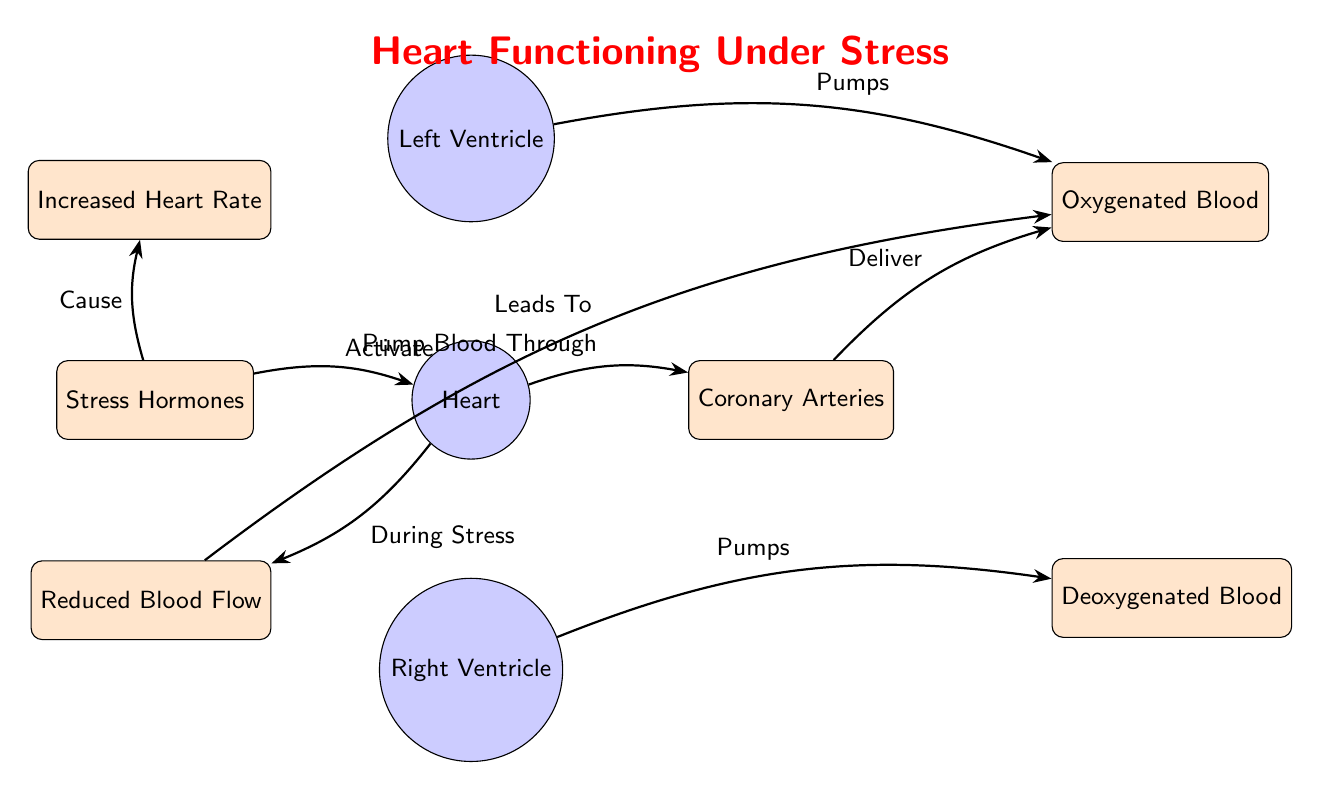What activates the heart during stress? The diagram indicates that "Stress Hormones" are responsible for activating the heart during stress as shown by the arrow from the "Stress Hormones" node to the "Heart" node labeled "Activate".
Answer: Stress Hormones What does the heart pump blood through? The diagram shows that the heart pumps blood through the "Coronary Arteries," as indicated by the arrow labeled "Pump Blood Through" from the heart to the coronary arteries.
Answer: Coronary Arteries How many processes are present in the diagram? There are three process nodes illustrated in the diagram: "Heart," "Left Ventricle," and "Right Ventricle." Counting these gives a total of three processes.
Answer: 3 Which node is affected by reduced blood flow? The diagram indicates that reduced blood flow ("Reduced Blood Flow") leads to oxygenated blood, as demonstrated by the arrow from "Reduced Blood Flow" to "Oxygenated Blood" labeled "Leads To".
Answer: Oxygenated Blood What relationship exists between increased heart rate and stress hormones? The diagram shows that stress hormones cause an increase in heart rate, as depicted by the arrow from "Stress Hormones" to "Increased Heart Rate" labeled "Cause".
Answer: Cause Which type of blood is delivered from the coronary arteries? According to the diagram, the coronary arteries deliver oxygenated blood, as indicated by the arrow from "Coronary Arteries" to "Oxygenated Blood" labeled "Deliver".
Answer: Oxygenated Blood What is the role of the left ventricle? The left ventricle is responsible for pumping oxygenated blood, as shown by the arrow from "Left Ventricle" to "Oxygenated Blood" labeled "Pumps".
Answer: Pumps Which nodes are present on the left side of the heart? The nodes present on the left side of the heart in the diagram are "Stress Hormones" and "Reduced Blood Flow", as indicated by their positions relative to the heart.
Answer: Stress Hormones, Reduced Blood Flow What does the heart do during stress according to the diagram? The diagram indicates that during stress, the heart can lead to reduced blood flow, as shown by the arrow from "Heart" to "Reduced Blood Flow" labeled "During Stress".
Answer: Reduced Blood Flow 